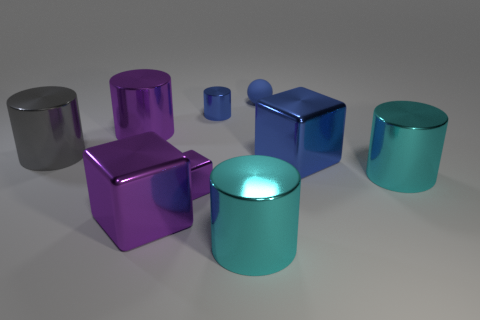What number of purple things are either small rubber spheres or small shiny cylinders?
Your answer should be very brief. 0. Is there a rubber ball of the same size as the blue block?
Provide a short and direct response. No. There is a blue cylinder that is the same size as the blue rubber thing; what material is it?
Provide a short and direct response. Metal. There is a blue thing that is behind the blue metal cylinder; does it have the same size as the metal object that is right of the big blue shiny object?
Offer a terse response. No. What number of things are tiny cubes or big cyan things that are behind the tiny shiny block?
Provide a succinct answer. 2. Are there any other tiny brown things of the same shape as the rubber thing?
Your response must be concise. No. There is a blue thing that is on the right side of the small blue matte object that is to the right of the blue shiny cylinder; how big is it?
Your answer should be very brief. Large. Does the small rubber ball have the same color as the small cylinder?
Ensure brevity in your answer.  Yes. How many rubber things are large gray cylinders or tiny balls?
Provide a succinct answer. 1. How many blue metallic things are there?
Offer a very short reply. 2. 